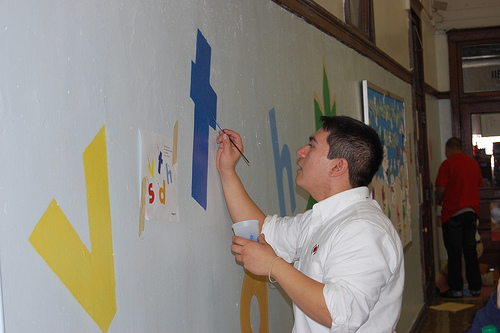<image>
Is the paint cup on the man? No. The paint cup is not positioned on the man. They may be near each other, but the paint cup is not supported by or resting on top of the man. 